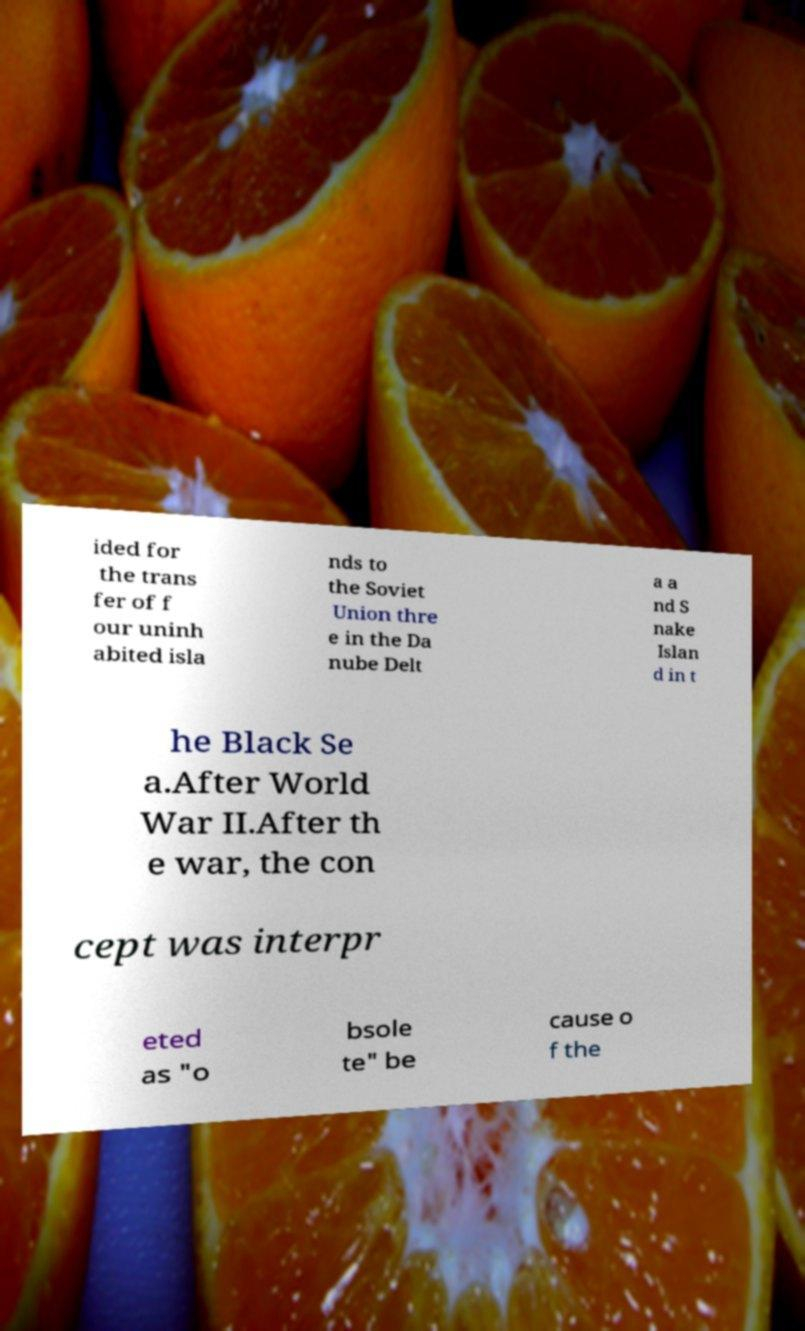Can you accurately transcribe the text from the provided image for me? ided for the trans fer of f our uninh abited isla nds to the Soviet Union thre e in the Da nube Delt a a nd S nake Islan d in t he Black Se a.After World War II.After th e war, the con cept was interpr eted as "o bsole te" be cause o f the 